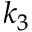<formula> <loc_0><loc_0><loc_500><loc_500>k _ { 3 }</formula> 